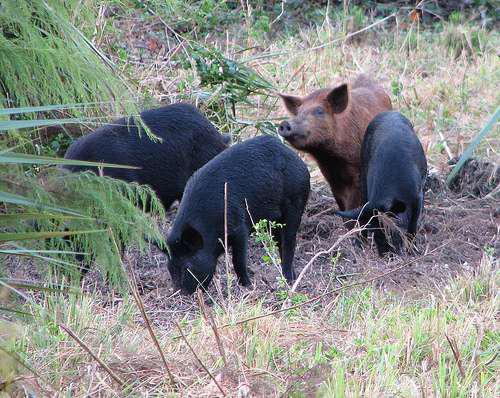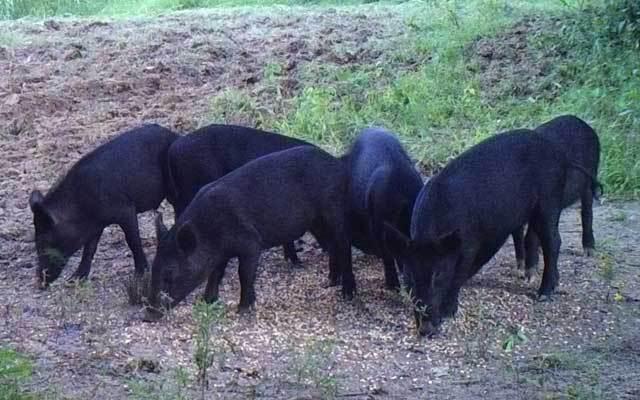The first image is the image on the left, the second image is the image on the right. Examine the images to the left and right. Is the description "One image prominently features a single mature pig standing in profile, and the other image includes at least one piglet with distinctive stripes." accurate? Answer yes or no. No. 